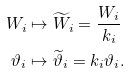Convert formula to latex. <formula><loc_0><loc_0><loc_500><loc_500>W _ { i } & \mapsto \widetilde { W } _ { i } = \frac { W _ { i } } { k _ { i } } \\ \vartheta _ { i } & \mapsto \widetilde { \vartheta } _ { i } = k _ { i } \vartheta _ { i } .</formula> 